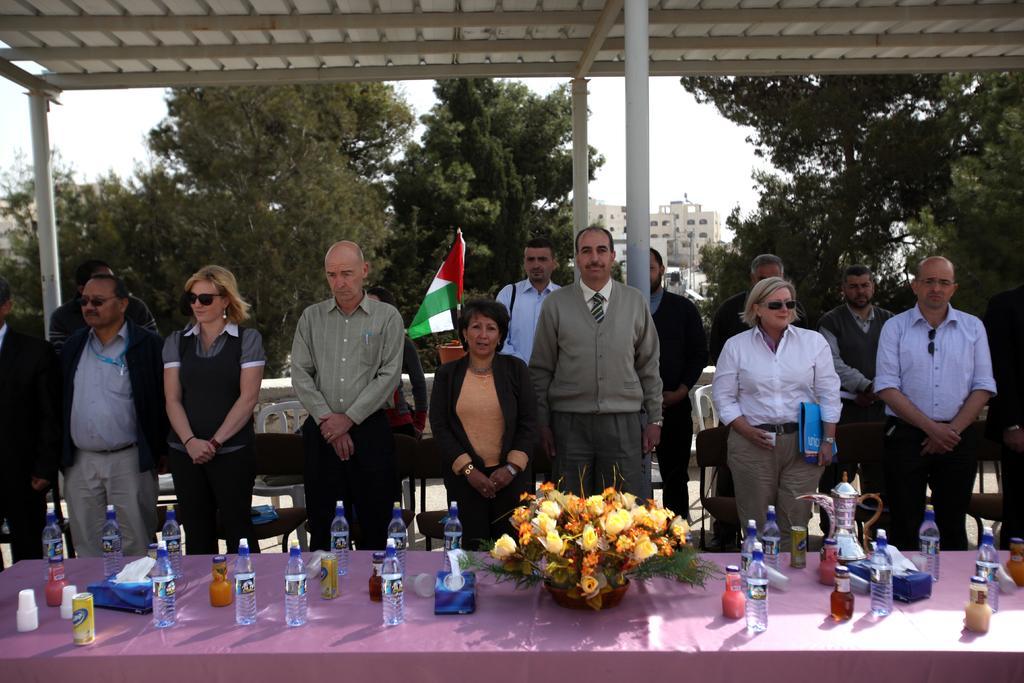Can you describe this image briefly? In this picture there is a group of men and women, standing in the front and giving a pose into the camera. In the front there is a table with water bottles, yellow flower basket. In the background we can see some white color building and trees. On the top there is a white color metal shed. 